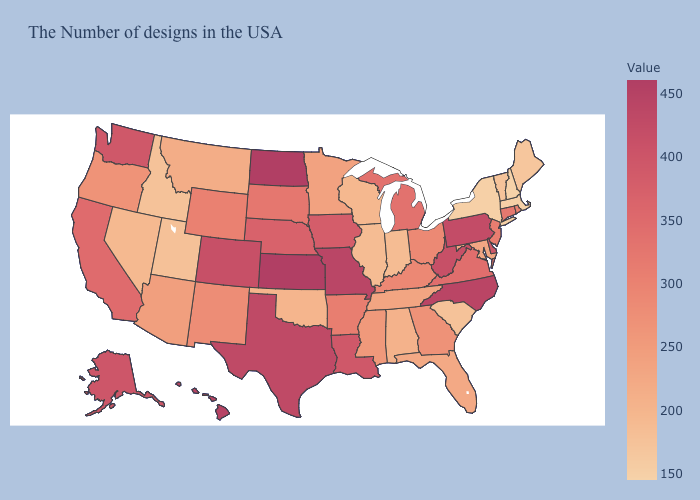Among the states that border Delaware , which have the highest value?
Be succinct. Pennsylvania. Among the states that border Minnesota , does Wisconsin have the lowest value?
Concise answer only. Yes. 